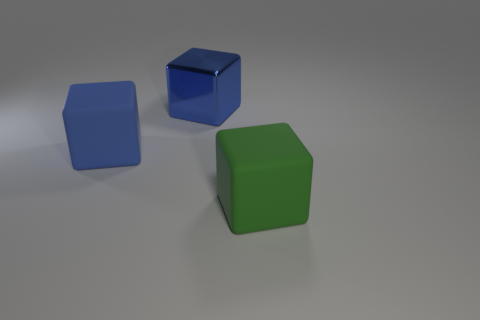There is a large object that is behind the big matte object that is to the left of the big green matte cube; what number of metal blocks are left of it? There are no metal blocks to the left of the large object behind the green cube in the image. It’s a clean, minimalistic scene with just three matte blocks in blue, green, and an undefined color with a smooth surface. 